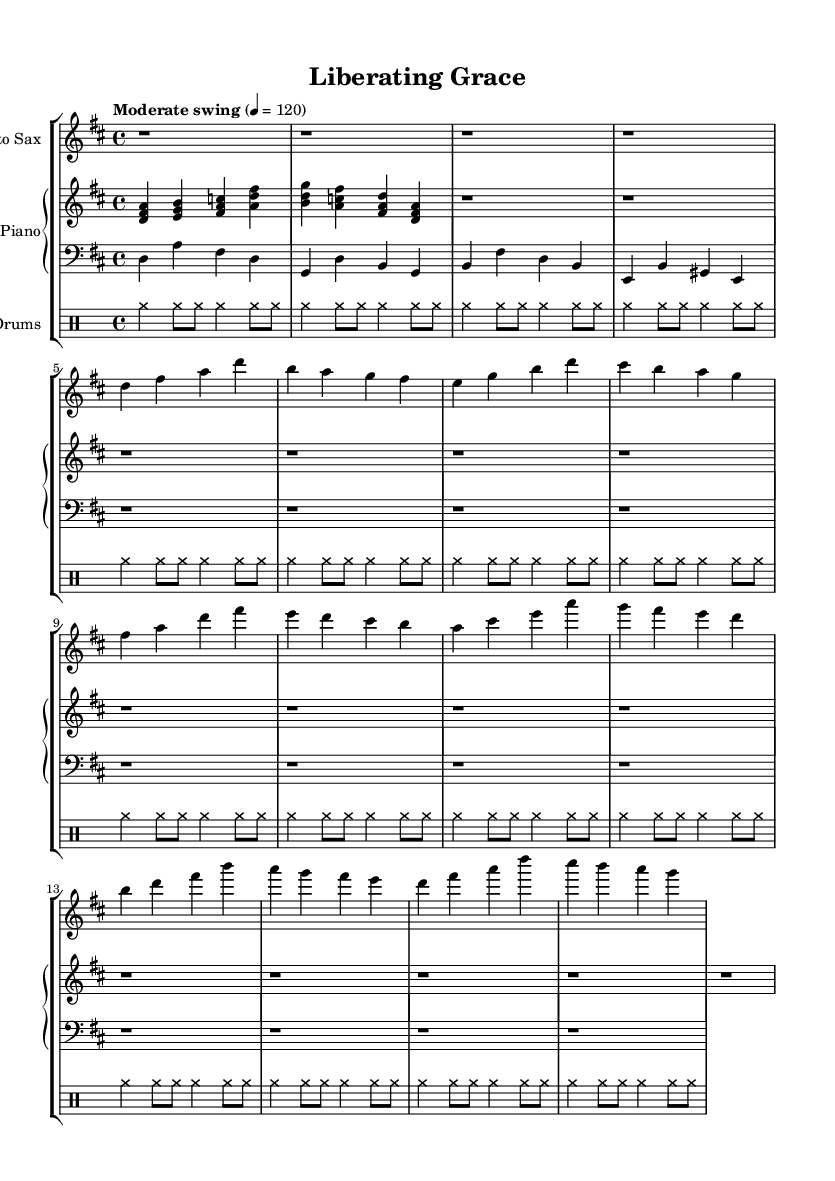What is the key signature of this music? The key signature is D major, which has two sharps (F# and C#). This can be identified by looking at the key signature notation at the beginning of the music.
Answer: D major What is the time signature of this composition? The time signature is 4/4, indicated at the beginning of the sheet music. This denotes that there are four beats in each measure and that a quarter note receives one beat.
Answer: 4/4 What is the tempo marking of this piece? The tempo marking is "Moderate swing", which suggests a relaxed and lively feel typical in jazz that encourages a swinging rhythm. It indicates the style rather than a specific metronome marking.
Answer: Moderate swing How many measures are notated in the saxophone part? There are a total of 12 measures indicated within the saxophone part. Each measure contains a mix of rests and notes representing a distinct musical idea. This can be counted visually along the staff.
Answer: 12 What instrument performs the accompaniment chords? The piano section is responsible for performing the accompaniment chords, which are indicated by the chord symbols and note groupings written in the treble staff of the piano part.
Answer: Piano What rhythmic style is associated with the drum part? The drumming style indicated is characterized by a swing feel, as shown in the repeated rhythmic patterns that suggest an underlying groove typical of jazz drumming.
Answer: Swing Which specific instrument is the melody played on? The melody is played on the Alto Sax, as indicated by the instrument name at the beginning of the staff. This instrument typically carries the lead melody in a jazz composition.
Answer: Alto Sax 